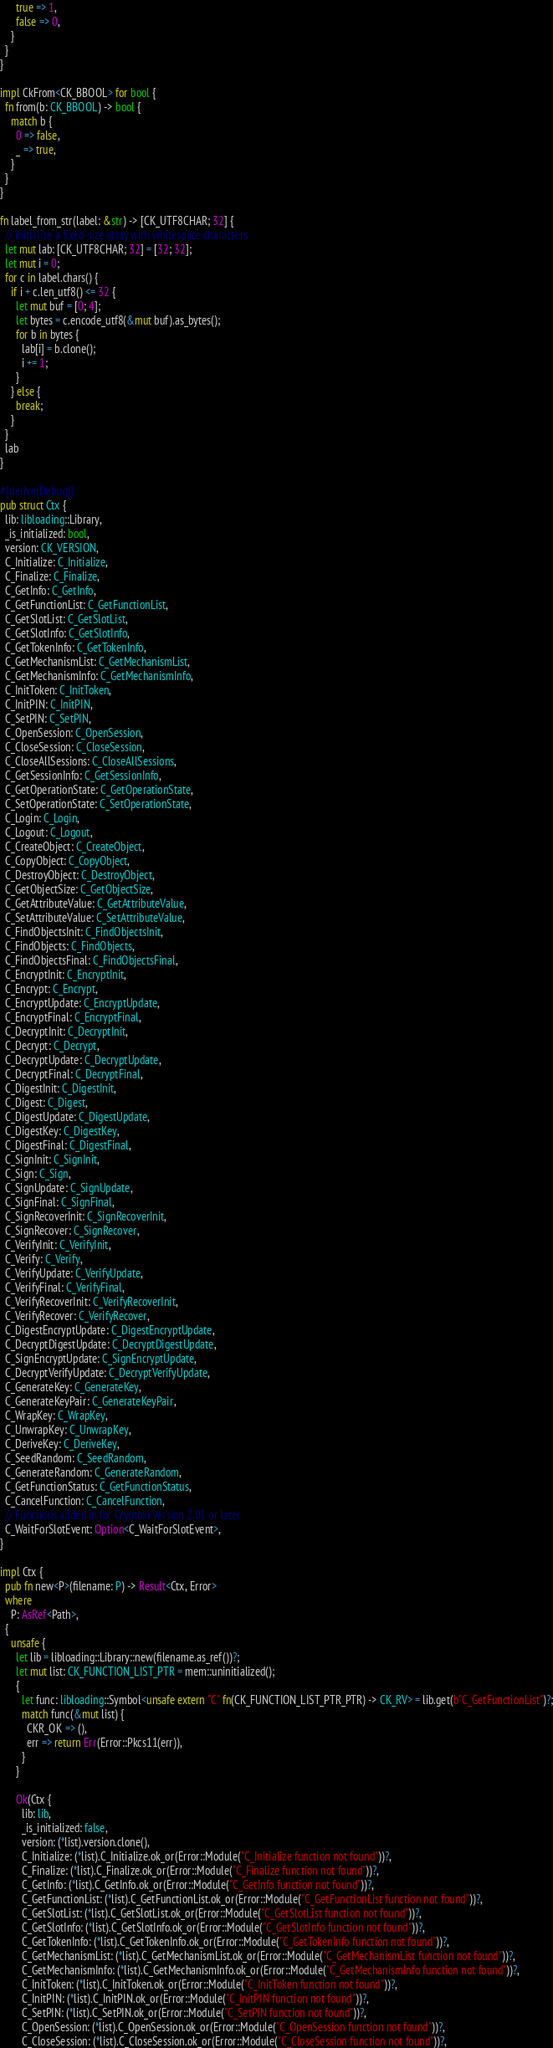<code> <loc_0><loc_0><loc_500><loc_500><_Rust_>      true => 1,
      false => 0,
    }
  }
}

impl CkFrom<CK_BBOOL> for bool {
  fn from(b: CK_BBOOL) -> bool {
    match b {
      0 => false,
      _ => true,
    }
  }
}

fn label_from_str(label: &str) -> [CK_UTF8CHAR; 32] {
  // initialize a fixed-size array with whitespace characters
  let mut lab: [CK_UTF8CHAR; 32] = [32; 32];
  let mut i = 0;
  for c in label.chars() {
    if i + c.len_utf8() <= 32 {
      let mut buf = [0; 4];
      let bytes = c.encode_utf8(&mut buf).as_bytes();
      for b in bytes {
        lab[i] = b.clone();
        i += 1;
      }
    } else {
      break;
    }
  }
  lab
}

#[derive(Debug)]
pub struct Ctx {
  lib: libloading::Library,
  _is_initialized: bool,
  version: CK_VERSION,
  C_Initialize: C_Initialize,
  C_Finalize: C_Finalize,
  C_GetInfo: C_GetInfo,
  C_GetFunctionList: C_GetFunctionList,
  C_GetSlotList: C_GetSlotList,
  C_GetSlotInfo: C_GetSlotInfo,
  C_GetTokenInfo: C_GetTokenInfo,
  C_GetMechanismList: C_GetMechanismList,
  C_GetMechanismInfo: C_GetMechanismInfo,
  C_InitToken: C_InitToken,
  C_InitPIN: C_InitPIN,
  C_SetPIN: C_SetPIN,
  C_OpenSession: C_OpenSession,
  C_CloseSession: C_CloseSession,
  C_CloseAllSessions: C_CloseAllSessions,
  C_GetSessionInfo: C_GetSessionInfo,
  C_GetOperationState: C_GetOperationState,
  C_SetOperationState: C_SetOperationState,
  C_Login: C_Login,
  C_Logout: C_Logout,
  C_CreateObject: C_CreateObject,
  C_CopyObject: C_CopyObject,
  C_DestroyObject: C_DestroyObject,
  C_GetObjectSize: C_GetObjectSize,
  C_GetAttributeValue: C_GetAttributeValue,
  C_SetAttributeValue: C_SetAttributeValue,
  C_FindObjectsInit: C_FindObjectsInit,
  C_FindObjects: C_FindObjects,
  C_FindObjectsFinal: C_FindObjectsFinal,
  C_EncryptInit: C_EncryptInit,
  C_Encrypt: C_Encrypt,
  C_EncryptUpdate: C_EncryptUpdate,
  C_EncryptFinal: C_EncryptFinal,
  C_DecryptInit: C_DecryptInit,
  C_Decrypt: C_Decrypt,
  C_DecryptUpdate: C_DecryptUpdate,
  C_DecryptFinal: C_DecryptFinal,
  C_DigestInit: C_DigestInit,
  C_Digest: C_Digest,
  C_DigestUpdate: C_DigestUpdate,
  C_DigestKey: C_DigestKey,
  C_DigestFinal: C_DigestFinal,
  C_SignInit: C_SignInit,
  C_Sign: C_Sign,
  C_SignUpdate: C_SignUpdate,
  C_SignFinal: C_SignFinal,
  C_SignRecoverInit: C_SignRecoverInit,
  C_SignRecover: C_SignRecover,
  C_VerifyInit: C_VerifyInit,
  C_Verify: C_Verify,
  C_VerifyUpdate: C_VerifyUpdate,
  C_VerifyFinal: C_VerifyFinal,
  C_VerifyRecoverInit: C_VerifyRecoverInit,
  C_VerifyRecover: C_VerifyRecover,
  C_DigestEncryptUpdate: C_DigestEncryptUpdate,
  C_DecryptDigestUpdate: C_DecryptDigestUpdate,
  C_SignEncryptUpdate: C_SignEncryptUpdate,
  C_DecryptVerifyUpdate: C_DecryptVerifyUpdate,
  C_GenerateKey: C_GenerateKey,
  C_GenerateKeyPair: C_GenerateKeyPair,
  C_WrapKey: C_WrapKey,
  C_UnwrapKey: C_UnwrapKey,
  C_DeriveKey: C_DeriveKey,
  C_SeedRandom: C_SeedRandom,
  C_GenerateRandom: C_GenerateRandom,
  C_GetFunctionStatus: C_GetFunctionStatus,
  C_CancelFunction: C_CancelFunction,
  // Functions added in for Cryptoki Version 2.01 or later
  C_WaitForSlotEvent: Option<C_WaitForSlotEvent>,
}

impl Ctx {
  pub fn new<P>(filename: P) -> Result<Ctx, Error>
  where
    P: AsRef<Path>,
  {
    unsafe {
      let lib = libloading::Library::new(filename.as_ref())?;
      let mut list: CK_FUNCTION_LIST_PTR = mem::uninitialized();
      {
        let func: libloading::Symbol<unsafe extern "C" fn(CK_FUNCTION_LIST_PTR_PTR) -> CK_RV> = lib.get(b"C_GetFunctionList")?;
        match func(&mut list) {
          CKR_OK => (),
          err => return Err(Error::Pkcs11(err)),
        }
      }

      Ok(Ctx {
        lib: lib,
        _is_initialized: false,
        version: (*list).version.clone(),
        C_Initialize: (*list).C_Initialize.ok_or(Error::Module("C_Initialize function not found"))?,
        C_Finalize: (*list).C_Finalize.ok_or(Error::Module("C_Finalize function not found"))?,
        C_GetInfo: (*list).C_GetInfo.ok_or(Error::Module("C_GetInfo function not found"))?,
        C_GetFunctionList: (*list).C_GetFunctionList.ok_or(Error::Module("C_GetFunctionList function not found"))?,
        C_GetSlotList: (*list).C_GetSlotList.ok_or(Error::Module("C_GetSlotList function not found"))?,
        C_GetSlotInfo: (*list).C_GetSlotInfo.ok_or(Error::Module("C_GetSlotInfo function not found"))?,
        C_GetTokenInfo: (*list).C_GetTokenInfo.ok_or(Error::Module("C_GetTokenInfo function not found"))?,
        C_GetMechanismList: (*list).C_GetMechanismList.ok_or(Error::Module("C_GetMechanismList function not found"))?,
        C_GetMechanismInfo: (*list).C_GetMechanismInfo.ok_or(Error::Module("C_GetMechanismInfo function not found"))?,
        C_InitToken: (*list).C_InitToken.ok_or(Error::Module("C_InitToken function not found"))?,
        C_InitPIN: (*list).C_InitPIN.ok_or(Error::Module("C_InitPIN function not found"))?,
        C_SetPIN: (*list).C_SetPIN.ok_or(Error::Module("C_SetPIN function not found"))?,
        C_OpenSession: (*list).C_OpenSession.ok_or(Error::Module("C_OpenSession function not found"))?,
        C_CloseSession: (*list).C_CloseSession.ok_or(Error::Module("C_CloseSession function not found"))?,</code> 